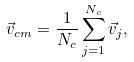<formula> <loc_0><loc_0><loc_500><loc_500>\vec { v } _ { c m } = \frac { 1 } { N _ { c } } \sum ^ { N _ { c } } _ { j = 1 } \vec { v } _ { j } ,</formula> 